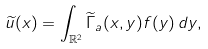Convert formula to latex. <formula><loc_0><loc_0><loc_500><loc_500>\widetilde { u } ( x ) = \int _ { \mathbb { R } ^ { 2 } } \widetilde { \Gamma } _ { a } ( x , y ) f ( y ) \, d y ,</formula> 